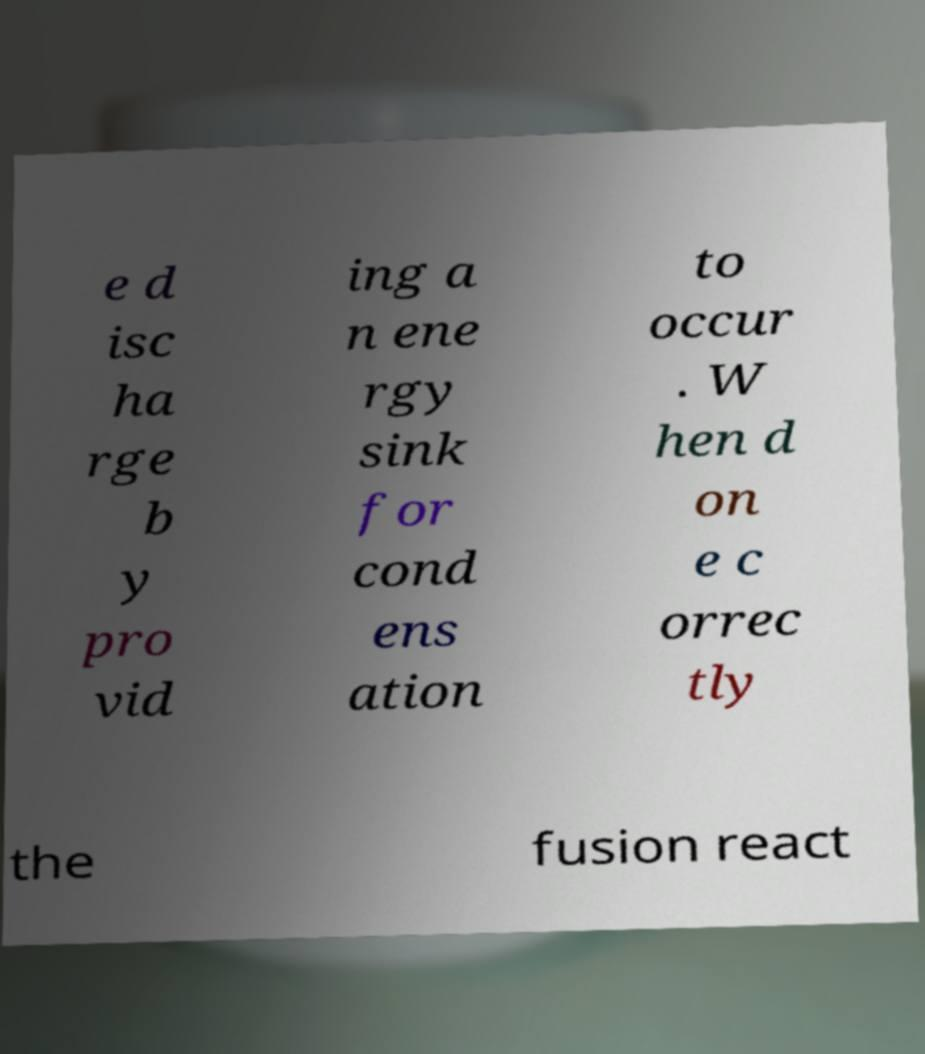Please identify and transcribe the text found in this image. e d isc ha rge b y pro vid ing a n ene rgy sink for cond ens ation to occur . W hen d on e c orrec tly the fusion react 